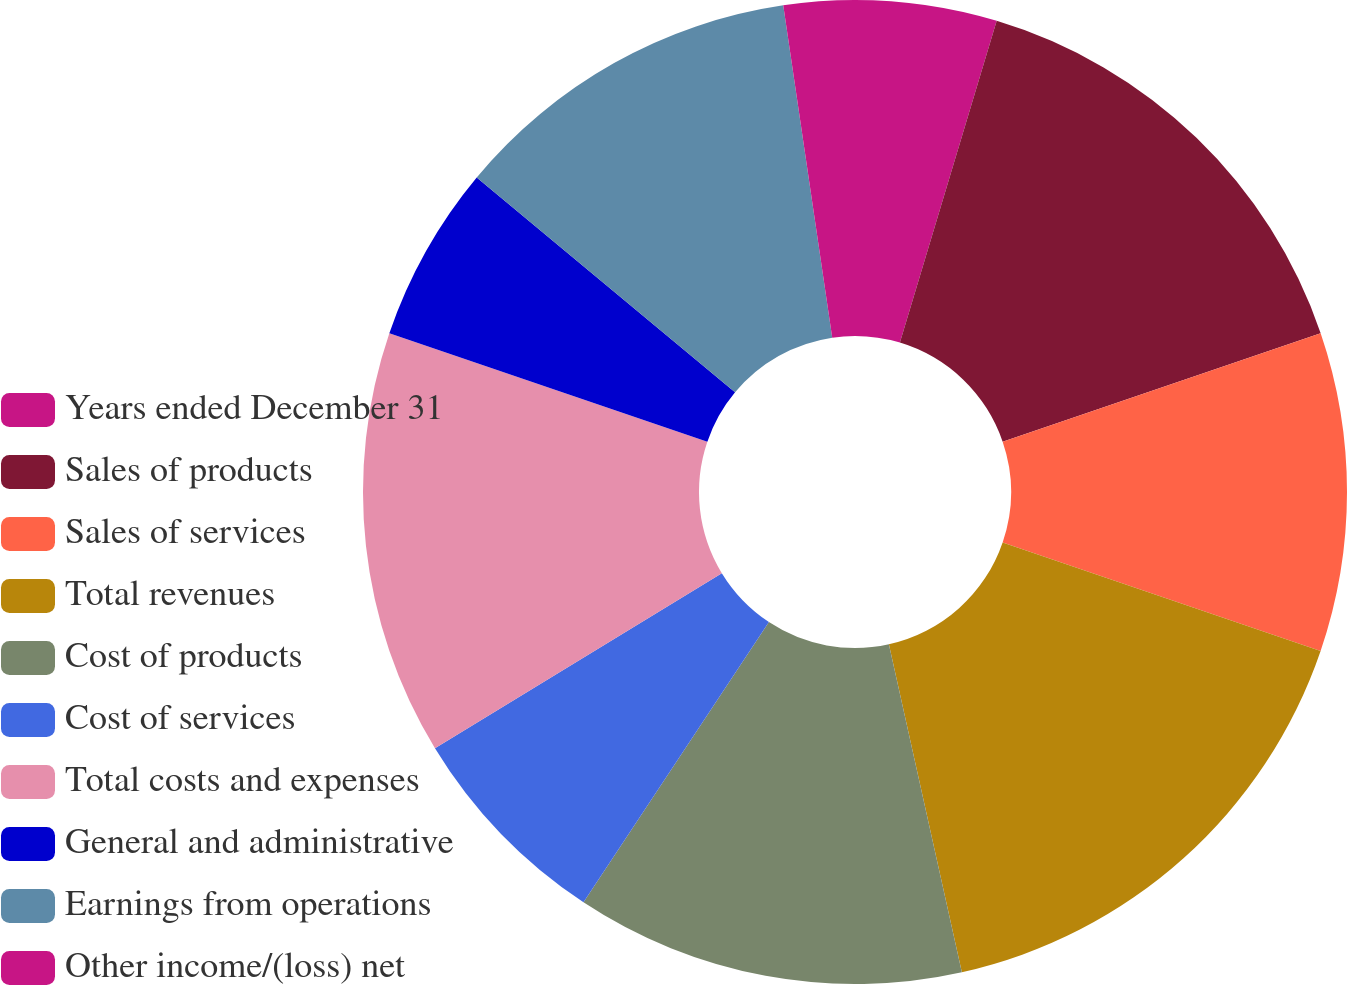Convert chart to OTSL. <chart><loc_0><loc_0><loc_500><loc_500><pie_chart><fcel>Years ended December 31<fcel>Sales of products<fcel>Sales of services<fcel>Total revenues<fcel>Cost of products<fcel>Cost of services<fcel>Total costs and expenses<fcel>General and administrative<fcel>Earnings from operations<fcel>Other income/(loss) net<nl><fcel>4.65%<fcel>15.12%<fcel>10.47%<fcel>16.28%<fcel>12.79%<fcel>6.98%<fcel>13.95%<fcel>5.81%<fcel>11.63%<fcel>2.33%<nl></chart> 